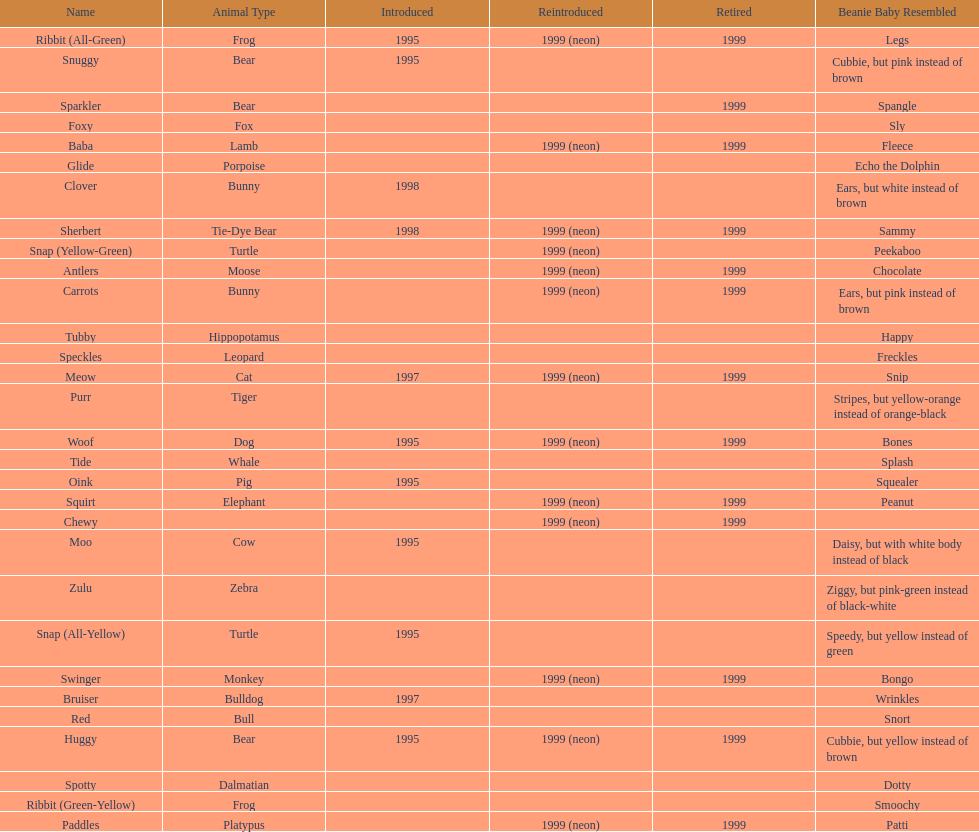Name the only pillow pal that is a dalmatian. Spotty. 